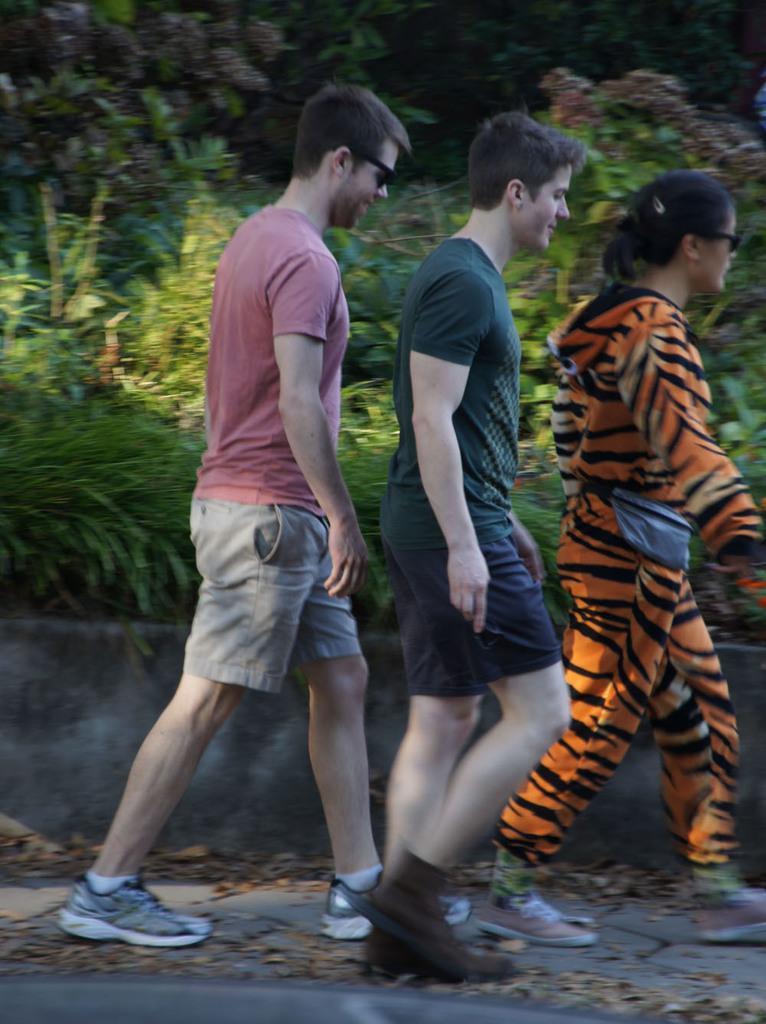How would you summarize this image in a sentence or two? In this picture I can see in the middle three persons are walking, they are wearing the shoes. In the background there are trees. 